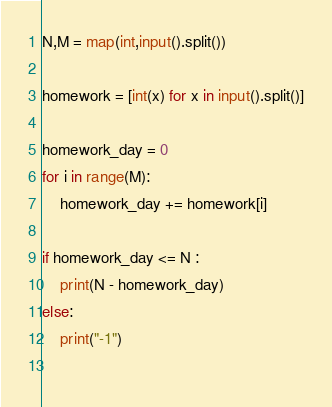<code> <loc_0><loc_0><loc_500><loc_500><_Python_>N,M = map(int,input().split())

homework = [int(x) for x in input().split()]

homework_day = 0
for i in range(M):
    homework_day += homework[i]

if homework_day <= N :
    print(N - homework_day)
else:
    print("-1")
    </code> 